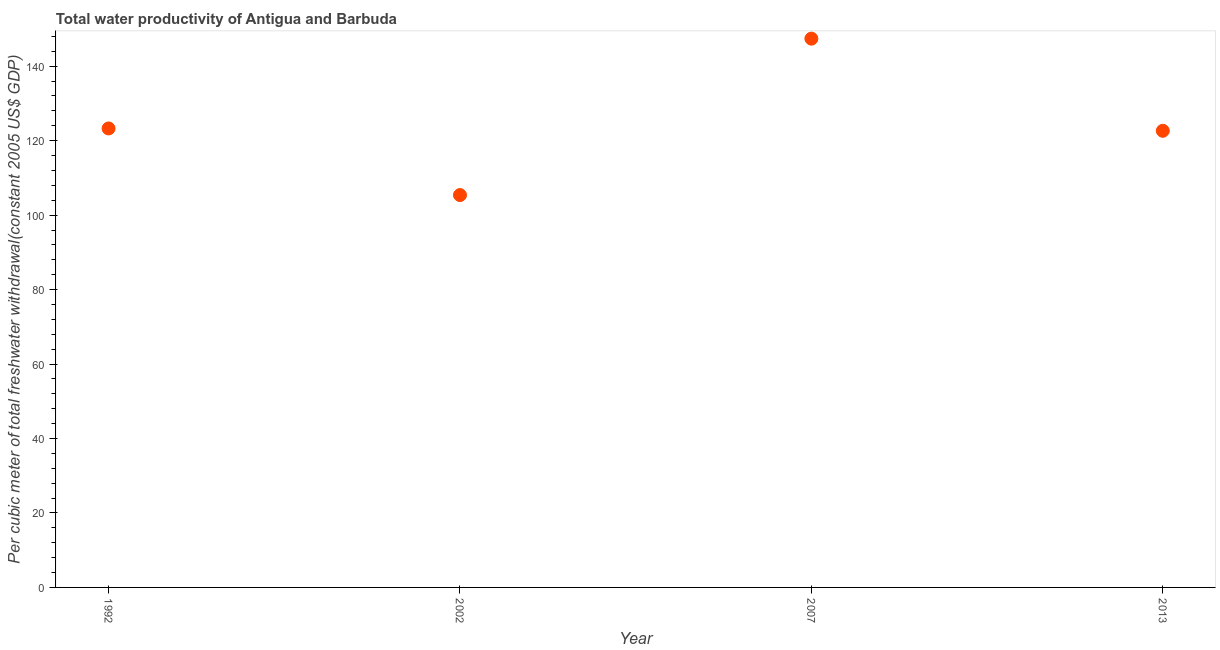What is the total water productivity in 1992?
Provide a short and direct response. 123.28. Across all years, what is the maximum total water productivity?
Provide a succinct answer. 147.4. Across all years, what is the minimum total water productivity?
Provide a short and direct response. 105.39. In which year was the total water productivity maximum?
Give a very brief answer. 2007. What is the sum of the total water productivity?
Your answer should be very brief. 498.73. What is the difference between the total water productivity in 1992 and 2013?
Offer a terse response. 0.63. What is the average total water productivity per year?
Your response must be concise. 124.68. What is the median total water productivity?
Provide a succinct answer. 122.97. Do a majority of the years between 2002 and 2007 (inclusive) have total water productivity greater than 24 US$?
Your answer should be compact. Yes. What is the ratio of the total water productivity in 2007 to that in 2013?
Your response must be concise. 1.2. Is the total water productivity in 2002 less than that in 2013?
Offer a terse response. Yes. Is the difference between the total water productivity in 1992 and 2002 greater than the difference between any two years?
Give a very brief answer. No. What is the difference between the highest and the second highest total water productivity?
Keep it short and to the point. 24.12. Is the sum of the total water productivity in 1992 and 2002 greater than the maximum total water productivity across all years?
Your answer should be very brief. Yes. What is the difference between the highest and the lowest total water productivity?
Provide a succinct answer. 42.02. In how many years, is the total water productivity greater than the average total water productivity taken over all years?
Ensure brevity in your answer.  1. Does the total water productivity monotonically increase over the years?
Provide a short and direct response. No. How many dotlines are there?
Keep it short and to the point. 1. How many years are there in the graph?
Ensure brevity in your answer.  4. Does the graph contain grids?
Keep it short and to the point. No. What is the title of the graph?
Your answer should be very brief. Total water productivity of Antigua and Barbuda. What is the label or title of the Y-axis?
Your answer should be very brief. Per cubic meter of total freshwater withdrawal(constant 2005 US$ GDP). What is the Per cubic meter of total freshwater withdrawal(constant 2005 US$ GDP) in 1992?
Give a very brief answer. 123.28. What is the Per cubic meter of total freshwater withdrawal(constant 2005 US$ GDP) in 2002?
Provide a succinct answer. 105.39. What is the Per cubic meter of total freshwater withdrawal(constant 2005 US$ GDP) in 2007?
Offer a terse response. 147.4. What is the Per cubic meter of total freshwater withdrawal(constant 2005 US$ GDP) in 2013?
Offer a terse response. 122.66. What is the difference between the Per cubic meter of total freshwater withdrawal(constant 2005 US$ GDP) in 1992 and 2002?
Give a very brief answer. 17.89. What is the difference between the Per cubic meter of total freshwater withdrawal(constant 2005 US$ GDP) in 1992 and 2007?
Your answer should be very brief. -24.12. What is the difference between the Per cubic meter of total freshwater withdrawal(constant 2005 US$ GDP) in 1992 and 2013?
Offer a very short reply. 0.63. What is the difference between the Per cubic meter of total freshwater withdrawal(constant 2005 US$ GDP) in 2002 and 2007?
Ensure brevity in your answer.  -42.02. What is the difference between the Per cubic meter of total freshwater withdrawal(constant 2005 US$ GDP) in 2002 and 2013?
Give a very brief answer. -17.27. What is the difference between the Per cubic meter of total freshwater withdrawal(constant 2005 US$ GDP) in 2007 and 2013?
Your answer should be compact. 24.75. What is the ratio of the Per cubic meter of total freshwater withdrawal(constant 2005 US$ GDP) in 1992 to that in 2002?
Provide a short and direct response. 1.17. What is the ratio of the Per cubic meter of total freshwater withdrawal(constant 2005 US$ GDP) in 1992 to that in 2007?
Your response must be concise. 0.84. What is the ratio of the Per cubic meter of total freshwater withdrawal(constant 2005 US$ GDP) in 1992 to that in 2013?
Provide a short and direct response. 1. What is the ratio of the Per cubic meter of total freshwater withdrawal(constant 2005 US$ GDP) in 2002 to that in 2007?
Your response must be concise. 0.71. What is the ratio of the Per cubic meter of total freshwater withdrawal(constant 2005 US$ GDP) in 2002 to that in 2013?
Keep it short and to the point. 0.86. What is the ratio of the Per cubic meter of total freshwater withdrawal(constant 2005 US$ GDP) in 2007 to that in 2013?
Ensure brevity in your answer.  1.2. 